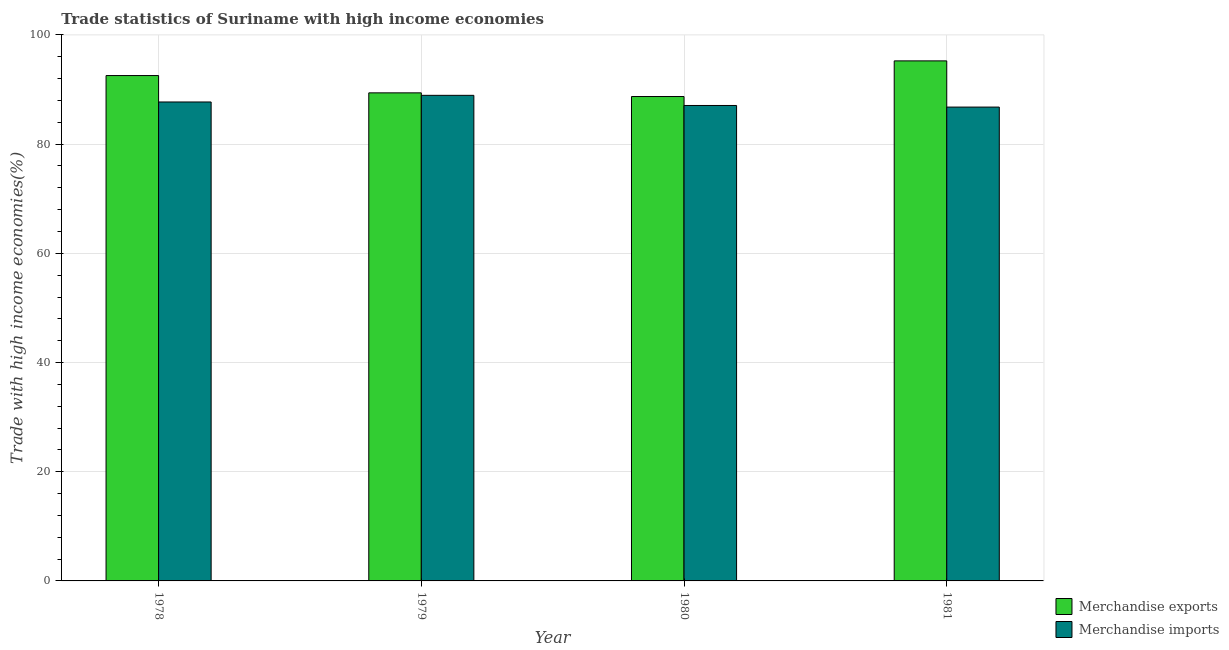Are the number of bars per tick equal to the number of legend labels?
Your answer should be very brief. Yes. How many bars are there on the 2nd tick from the right?
Provide a short and direct response. 2. What is the label of the 1st group of bars from the left?
Offer a terse response. 1978. What is the merchandise imports in 1980?
Offer a very short reply. 87.08. Across all years, what is the maximum merchandise exports?
Your response must be concise. 95.25. Across all years, what is the minimum merchandise exports?
Keep it short and to the point. 88.72. In which year was the merchandise imports maximum?
Keep it short and to the point. 1979. What is the total merchandise imports in the graph?
Provide a succinct answer. 350.51. What is the difference between the merchandise exports in 1978 and that in 1981?
Your answer should be compact. -2.69. What is the difference between the merchandise imports in 1979 and the merchandise exports in 1980?
Your answer should be compact. 1.86. What is the average merchandise exports per year?
Your response must be concise. 91.48. What is the ratio of the merchandise imports in 1979 to that in 1981?
Keep it short and to the point. 1.02. Is the difference between the merchandise imports in 1978 and 1980 greater than the difference between the merchandise exports in 1978 and 1980?
Offer a terse response. No. What is the difference between the highest and the second highest merchandise imports?
Offer a very short reply. 1.21. What is the difference between the highest and the lowest merchandise exports?
Offer a terse response. 6.53. In how many years, is the merchandise imports greater than the average merchandise imports taken over all years?
Provide a short and direct response. 2. Is the sum of the merchandise imports in 1979 and 1981 greater than the maximum merchandise exports across all years?
Offer a terse response. Yes. What does the 2nd bar from the left in 1978 represents?
Ensure brevity in your answer.  Merchandise imports. Are all the bars in the graph horizontal?
Keep it short and to the point. No. What is the difference between two consecutive major ticks on the Y-axis?
Give a very brief answer. 20. Are the values on the major ticks of Y-axis written in scientific E-notation?
Offer a very short reply. No. Does the graph contain grids?
Your answer should be compact. Yes. Where does the legend appear in the graph?
Offer a terse response. Bottom right. How many legend labels are there?
Give a very brief answer. 2. What is the title of the graph?
Offer a very short reply. Trade statistics of Suriname with high income economies. What is the label or title of the Y-axis?
Offer a terse response. Trade with high income economies(%). What is the Trade with high income economies(%) of Merchandise exports in 1978?
Give a very brief answer. 92.56. What is the Trade with high income economies(%) of Merchandise imports in 1978?
Provide a succinct answer. 87.72. What is the Trade with high income economies(%) in Merchandise exports in 1979?
Your answer should be very brief. 89.39. What is the Trade with high income economies(%) in Merchandise imports in 1979?
Your answer should be compact. 88.93. What is the Trade with high income economies(%) of Merchandise exports in 1980?
Give a very brief answer. 88.72. What is the Trade with high income economies(%) of Merchandise imports in 1980?
Give a very brief answer. 87.08. What is the Trade with high income economies(%) in Merchandise exports in 1981?
Provide a short and direct response. 95.25. What is the Trade with high income economies(%) of Merchandise imports in 1981?
Keep it short and to the point. 86.78. Across all years, what is the maximum Trade with high income economies(%) of Merchandise exports?
Give a very brief answer. 95.25. Across all years, what is the maximum Trade with high income economies(%) in Merchandise imports?
Ensure brevity in your answer.  88.93. Across all years, what is the minimum Trade with high income economies(%) of Merchandise exports?
Ensure brevity in your answer.  88.72. Across all years, what is the minimum Trade with high income economies(%) of Merchandise imports?
Offer a terse response. 86.78. What is the total Trade with high income economies(%) of Merchandise exports in the graph?
Offer a very short reply. 365.91. What is the total Trade with high income economies(%) of Merchandise imports in the graph?
Keep it short and to the point. 350.51. What is the difference between the Trade with high income economies(%) in Merchandise exports in 1978 and that in 1979?
Offer a terse response. 3.17. What is the difference between the Trade with high income economies(%) in Merchandise imports in 1978 and that in 1979?
Make the answer very short. -1.21. What is the difference between the Trade with high income economies(%) in Merchandise exports in 1978 and that in 1980?
Your answer should be very brief. 3.84. What is the difference between the Trade with high income economies(%) of Merchandise imports in 1978 and that in 1980?
Give a very brief answer. 0.64. What is the difference between the Trade with high income economies(%) in Merchandise exports in 1978 and that in 1981?
Your answer should be compact. -2.69. What is the difference between the Trade with high income economies(%) in Merchandise imports in 1978 and that in 1981?
Keep it short and to the point. 0.94. What is the difference between the Trade with high income economies(%) of Merchandise exports in 1979 and that in 1980?
Give a very brief answer. 0.67. What is the difference between the Trade with high income economies(%) in Merchandise imports in 1979 and that in 1980?
Your answer should be very brief. 1.86. What is the difference between the Trade with high income economies(%) in Merchandise exports in 1979 and that in 1981?
Your answer should be very brief. -5.86. What is the difference between the Trade with high income economies(%) in Merchandise imports in 1979 and that in 1981?
Ensure brevity in your answer.  2.15. What is the difference between the Trade with high income economies(%) of Merchandise exports in 1980 and that in 1981?
Your answer should be compact. -6.53. What is the difference between the Trade with high income economies(%) in Merchandise imports in 1980 and that in 1981?
Provide a short and direct response. 0.29. What is the difference between the Trade with high income economies(%) of Merchandise exports in 1978 and the Trade with high income economies(%) of Merchandise imports in 1979?
Provide a succinct answer. 3.63. What is the difference between the Trade with high income economies(%) in Merchandise exports in 1978 and the Trade with high income economies(%) in Merchandise imports in 1980?
Offer a terse response. 5.48. What is the difference between the Trade with high income economies(%) in Merchandise exports in 1978 and the Trade with high income economies(%) in Merchandise imports in 1981?
Offer a terse response. 5.78. What is the difference between the Trade with high income economies(%) in Merchandise exports in 1979 and the Trade with high income economies(%) in Merchandise imports in 1980?
Offer a very short reply. 2.31. What is the difference between the Trade with high income economies(%) of Merchandise exports in 1979 and the Trade with high income economies(%) of Merchandise imports in 1981?
Provide a succinct answer. 2.6. What is the difference between the Trade with high income economies(%) of Merchandise exports in 1980 and the Trade with high income economies(%) of Merchandise imports in 1981?
Offer a terse response. 1.93. What is the average Trade with high income economies(%) of Merchandise exports per year?
Make the answer very short. 91.48. What is the average Trade with high income economies(%) of Merchandise imports per year?
Provide a short and direct response. 87.63. In the year 1978, what is the difference between the Trade with high income economies(%) of Merchandise exports and Trade with high income economies(%) of Merchandise imports?
Offer a very short reply. 4.84. In the year 1979, what is the difference between the Trade with high income economies(%) in Merchandise exports and Trade with high income economies(%) in Merchandise imports?
Provide a succinct answer. 0.46. In the year 1980, what is the difference between the Trade with high income economies(%) of Merchandise exports and Trade with high income economies(%) of Merchandise imports?
Ensure brevity in your answer.  1.64. In the year 1981, what is the difference between the Trade with high income economies(%) of Merchandise exports and Trade with high income economies(%) of Merchandise imports?
Your answer should be compact. 8.46. What is the ratio of the Trade with high income economies(%) of Merchandise exports in 1978 to that in 1979?
Your answer should be compact. 1.04. What is the ratio of the Trade with high income economies(%) of Merchandise imports in 1978 to that in 1979?
Offer a terse response. 0.99. What is the ratio of the Trade with high income economies(%) of Merchandise exports in 1978 to that in 1980?
Provide a succinct answer. 1.04. What is the ratio of the Trade with high income economies(%) of Merchandise imports in 1978 to that in 1980?
Provide a short and direct response. 1.01. What is the ratio of the Trade with high income economies(%) in Merchandise exports in 1978 to that in 1981?
Your answer should be very brief. 0.97. What is the ratio of the Trade with high income economies(%) of Merchandise imports in 1978 to that in 1981?
Give a very brief answer. 1.01. What is the ratio of the Trade with high income economies(%) of Merchandise exports in 1979 to that in 1980?
Ensure brevity in your answer.  1.01. What is the ratio of the Trade with high income economies(%) of Merchandise imports in 1979 to that in 1980?
Provide a succinct answer. 1.02. What is the ratio of the Trade with high income economies(%) in Merchandise exports in 1979 to that in 1981?
Provide a succinct answer. 0.94. What is the ratio of the Trade with high income economies(%) in Merchandise imports in 1979 to that in 1981?
Your answer should be compact. 1.02. What is the ratio of the Trade with high income economies(%) in Merchandise exports in 1980 to that in 1981?
Offer a terse response. 0.93. What is the difference between the highest and the second highest Trade with high income economies(%) in Merchandise exports?
Offer a terse response. 2.69. What is the difference between the highest and the second highest Trade with high income economies(%) in Merchandise imports?
Ensure brevity in your answer.  1.21. What is the difference between the highest and the lowest Trade with high income economies(%) of Merchandise exports?
Keep it short and to the point. 6.53. What is the difference between the highest and the lowest Trade with high income economies(%) in Merchandise imports?
Ensure brevity in your answer.  2.15. 